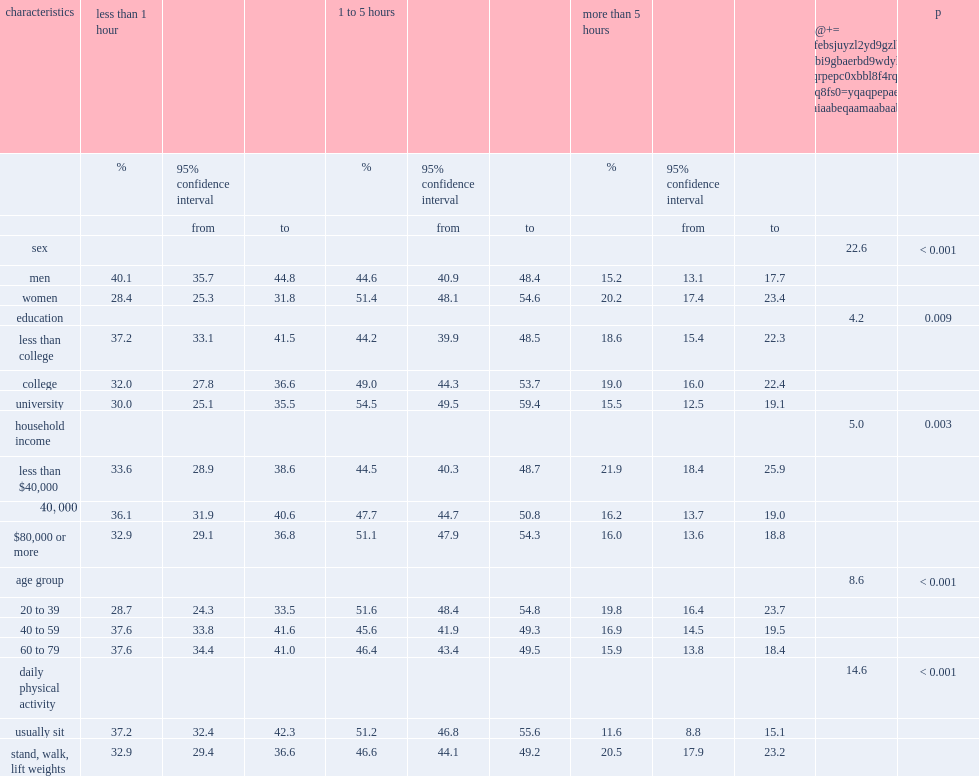Among which sex people engaging in utilitarian walking more than 5 hours a week was more prevalent? Women. Among which age group people engaging in utilitarian walking more than 5 hours a week was more prevalent? 20 to 39. Among which education group people engaging in utilitarian walking more than 5 hours a week was more prevalent, those who did not have a university degree, or those who had? Less than college college. Among which household income group people engaging in utilitarian walking more than 5 hours a week was more prevalent? Less than $40,000. According to daily physical activity, among which group people engaging in utilitarian walking more than 5 hours a week was more prevalent? Stand, walk, lift weights. 